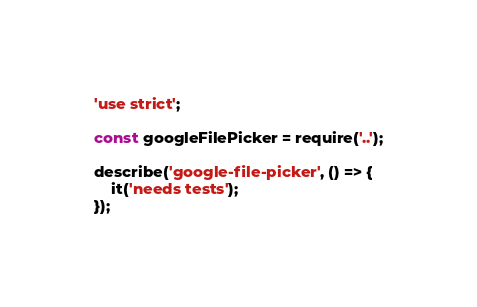<code> <loc_0><loc_0><loc_500><loc_500><_JavaScript_>'use strict';

const googleFilePicker = require('..');

describe('google-file-picker', () => {
    it('needs tests');
});
</code> 